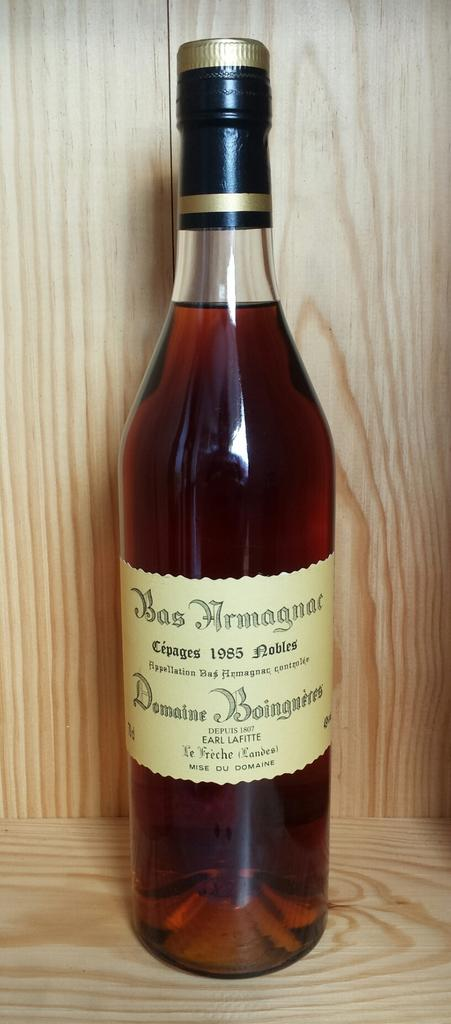<image>
Give a short and clear explanation of the subsequent image. a wine bottle with a label that says BasArmagnae 